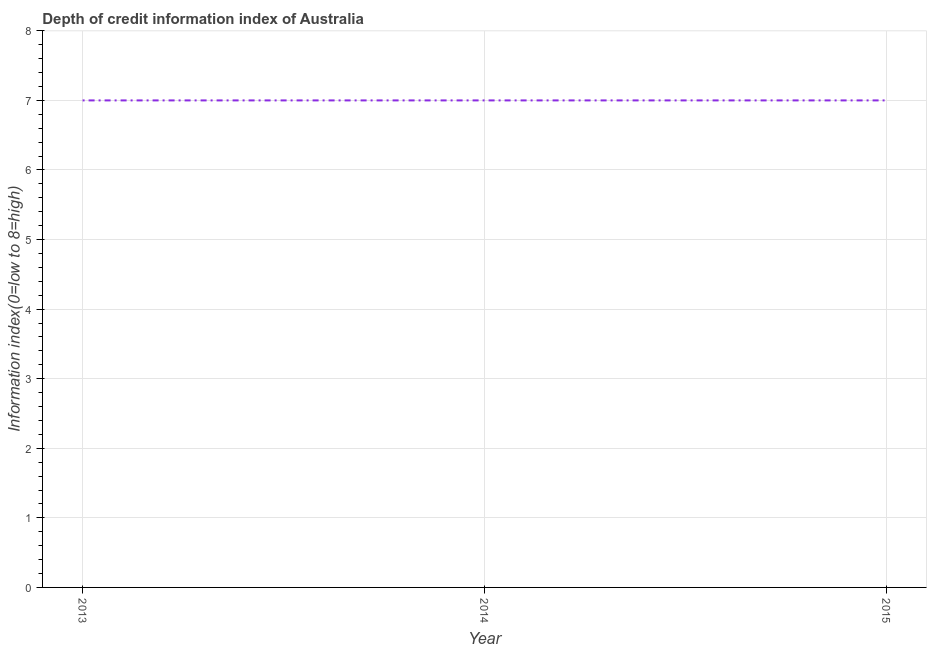What is the depth of credit information index in 2013?
Provide a succinct answer. 7. Across all years, what is the maximum depth of credit information index?
Keep it short and to the point. 7. Across all years, what is the minimum depth of credit information index?
Offer a terse response. 7. In which year was the depth of credit information index minimum?
Provide a succinct answer. 2013. What is the sum of the depth of credit information index?
Your answer should be very brief. 21. What is the average depth of credit information index per year?
Provide a succinct answer. 7. In how many years, is the depth of credit information index greater than 6 ?
Your response must be concise. 3. Is the depth of credit information index in 2013 less than that in 2015?
Your answer should be very brief. No. Is the difference between the depth of credit information index in 2013 and 2014 greater than the difference between any two years?
Your answer should be compact. Yes. In how many years, is the depth of credit information index greater than the average depth of credit information index taken over all years?
Keep it short and to the point. 0. Does the depth of credit information index monotonically increase over the years?
Offer a terse response. No. Does the graph contain any zero values?
Give a very brief answer. No. What is the title of the graph?
Give a very brief answer. Depth of credit information index of Australia. What is the label or title of the Y-axis?
Provide a short and direct response. Information index(0=low to 8=high). What is the Information index(0=low to 8=high) of 2013?
Make the answer very short. 7. What is the Information index(0=low to 8=high) of 2014?
Provide a succinct answer. 7. What is the Information index(0=low to 8=high) in 2015?
Provide a succinct answer. 7. What is the difference between the Information index(0=low to 8=high) in 2013 and 2014?
Offer a very short reply. 0. What is the ratio of the Information index(0=low to 8=high) in 2013 to that in 2014?
Ensure brevity in your answer.  1. What is the ratio of the Information index(0=low to 8=high) in 2013 to that in 2015?
Give a very brief answer. 1. What is the ratio of the Information index(0=low to 8=high) in 2014 to that in 2015?
Provide a succinct answer. 1. 